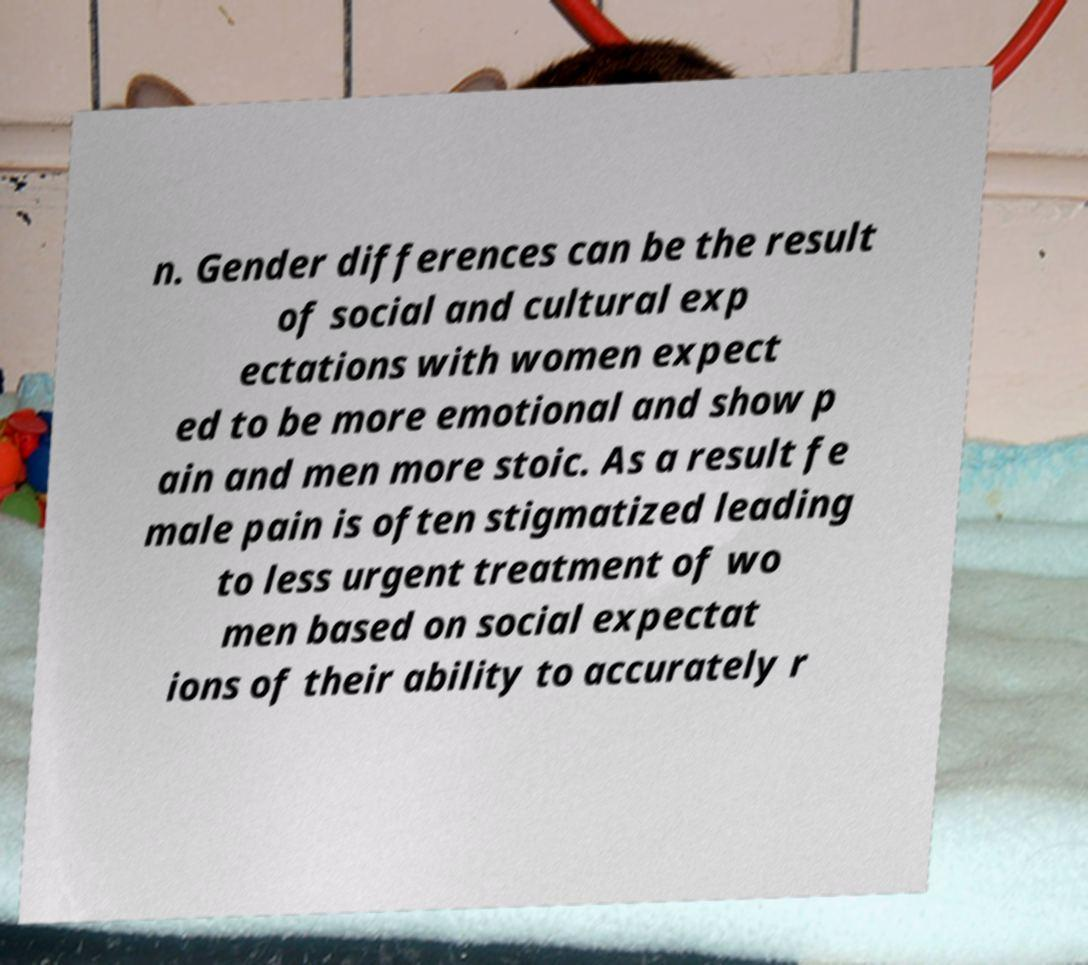Could you assist in decoding the text presented in this image and type it out clearly? n. Gender differences can be the result of social and cultural exp ectations with women expect ed to be more emotional and show p ain and men more stoic. As a result fe male pain is often stigmatized leading to less urgent treatment of wo men based on social expectat ions of their ability to accurately r 